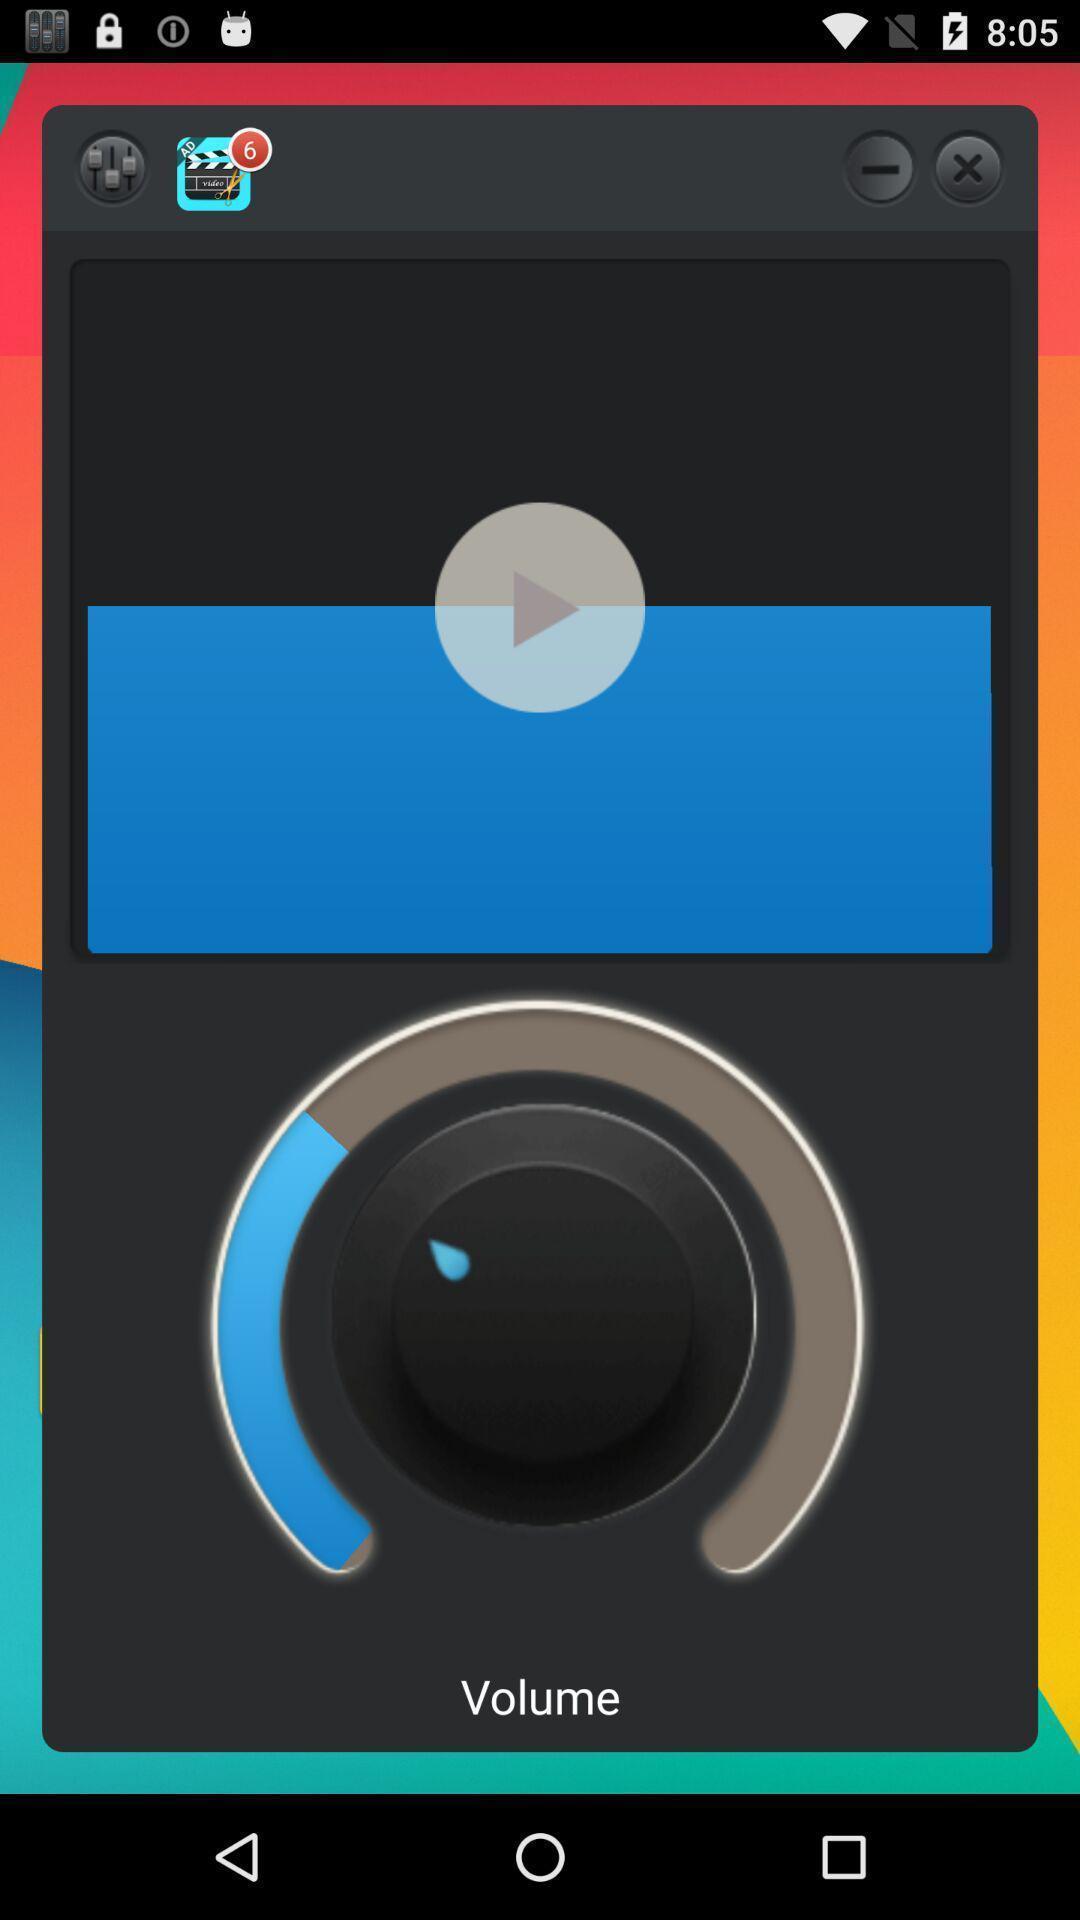Summarize the main components in this picture. Screen shows different options in a music app. 